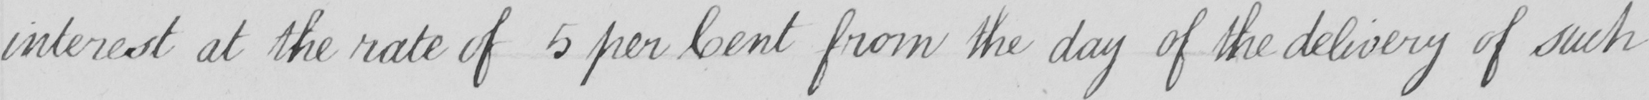Transcribe the text shown in this historical manuscript line. interest at the rate of 5 per Cent from the day of the delivery of such 